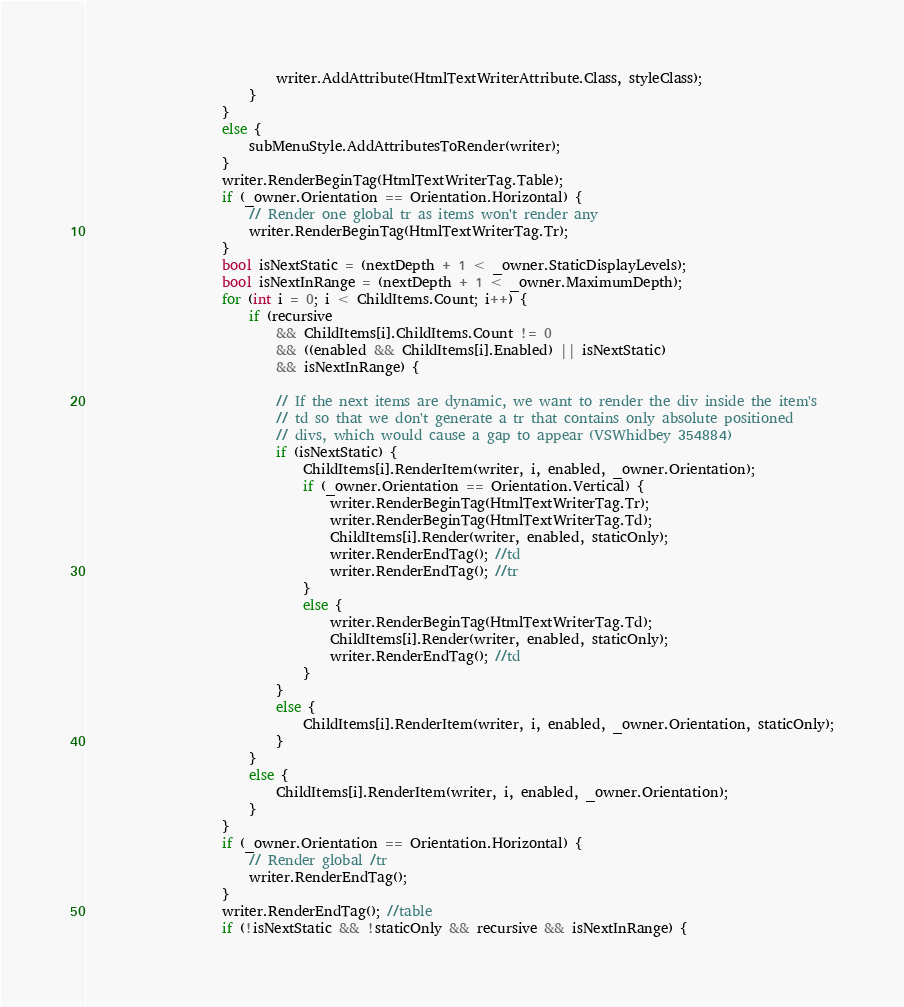Convert code to text. <code><loc_0><loc_0><loc_500><loc_500><_C#_>                            writer.AddAttribute(HtmlTextWriterAttribute.Class, styleClass);
                        }
                    }
                    else {
                        subMenuStyle.AddAttributesToRender(writer);
                    }
                    writer.RenderBeginTag(HtmlTextWriterTag.Table);
                    if (_owner.Orientation == Orientation.Horizontal) {
                        // Render one global tr as items won't render any
                        writer.RenderBeginTag(HtmlTextWriterTag.Tr);
                    }
                    bool isNextStatic = (nextDepth + 1 < _owner.StaticDisplayLevels);
                    bool isNextInRange = (nextDepth + 1 < _owner.MaximumDepth);
                    for (int i = 0; i < ChildItems.Count; i++) {
                        if (recursive
                            && ChildItems[i].ChildItems.Count != 0
                            && ((enabled && ChildItems[i].Enabled) || isNextStatic)
                            && isNextInRange) {

                            // If the next items are dynamic, we want to render the div inside the item's
                            // td so that we don't generate a tr that contains only absolute positioned
                            // divs, which would cause a gap to appear (VSWhidbey 354884)
                            if (isNextStatic) {
                                ChildItems[i].RenderItem(writer, i, enabled, _owner.Orientation);
                                if (_owner.Orientation == Orientation.Vertical) {
                                    writer.RenderBeginTag(HtmlTextWriterTag.Tr);
                                    writer.RenderBeginTag(HtmlTextWriterTag.Td);
                                    ChildItems[i].Render(writer, enabled, staticOnly);
                                    writer.RenderEndTag(); //td
                                    writer.RenderEndTag(); //tr
                                }
                                else {
                                    writer.RenderBeginTag(HtmlTextWriterTag.Td);
                                    ChildItems[i].Render(writer, enabled, staticOnly);
                                    writer.RenderEndTag(); //td
                                }
                            }
                            else {
                                ChildItems[i].RenderItem(writer, i, enabled, _owner.Orientation, staticOnly);
                            }
                        }
                        else {
                            ChildItems[i].RenderItem(writer, i, enabled, _owner.Orientation);
                        }
                    }
                    if (_owner.Orientation == Orientation.Horizontal) {
                        // Render global /tr
                        writer.RenderEndTag();
                    }
                    writer.RenderEndTag(); //table
                    if (!isNextStatic && !staticOnly && recursive && isNextInRange) {</code> 